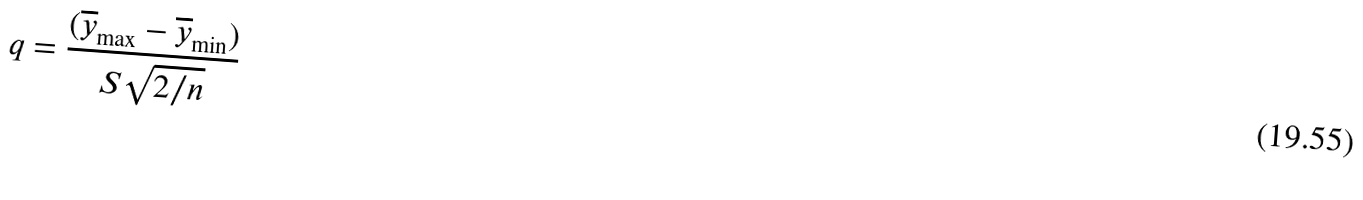<formula> <loc_0><loc_0><loc_500><loc_500>q = \frac { ( \overline { y } _ { \max } - \overline { y } _ { \min } ) } { S \sqrt { 2 / n } }</formula> 